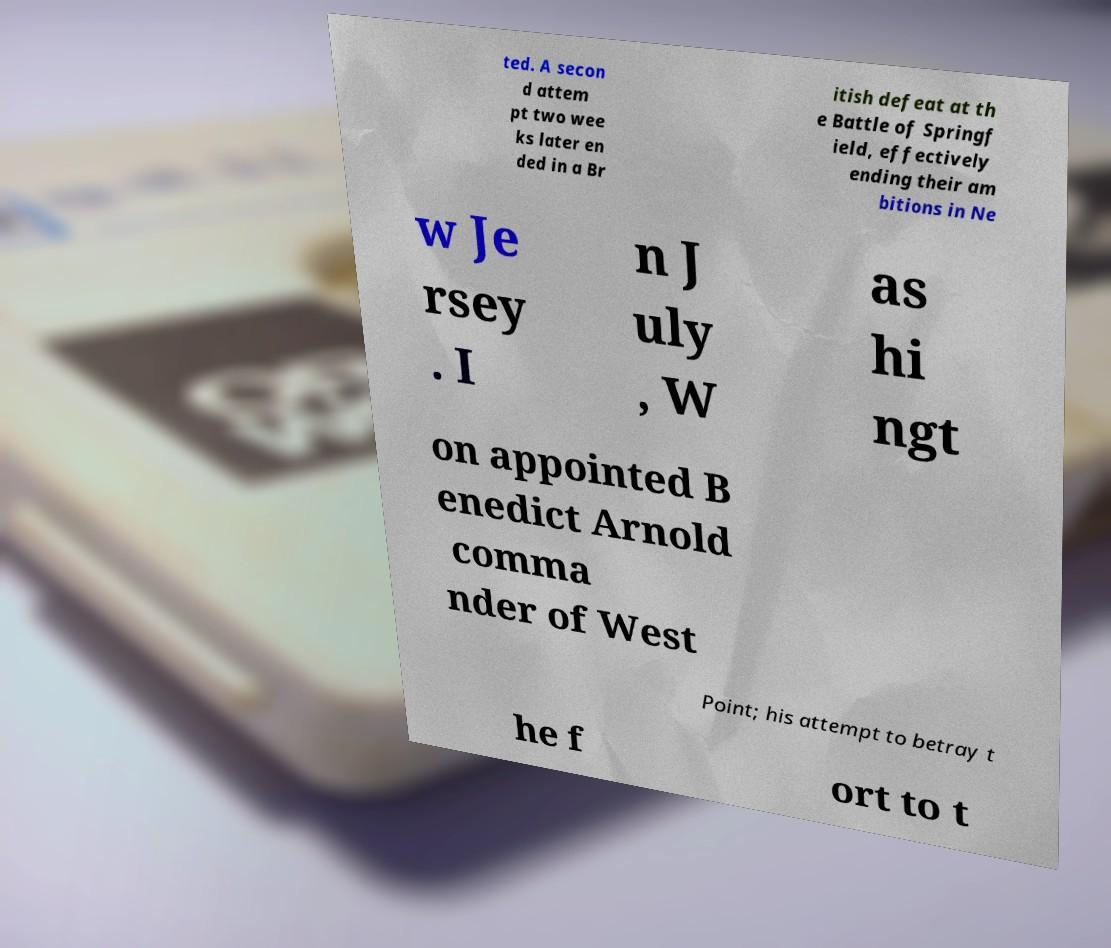Please read and relay the text visible in this image. What does it say? ted. A secon d attem pt two wee ks later en ded in a Br itish defeat at th e Battle of Springf ield, effectively ending their am bitions in Ne w Je rsey . I n J uly , W as hi ngt on appointed B enedict Arnold comma nder of West Point; his attempt to betray t he f ort to t 